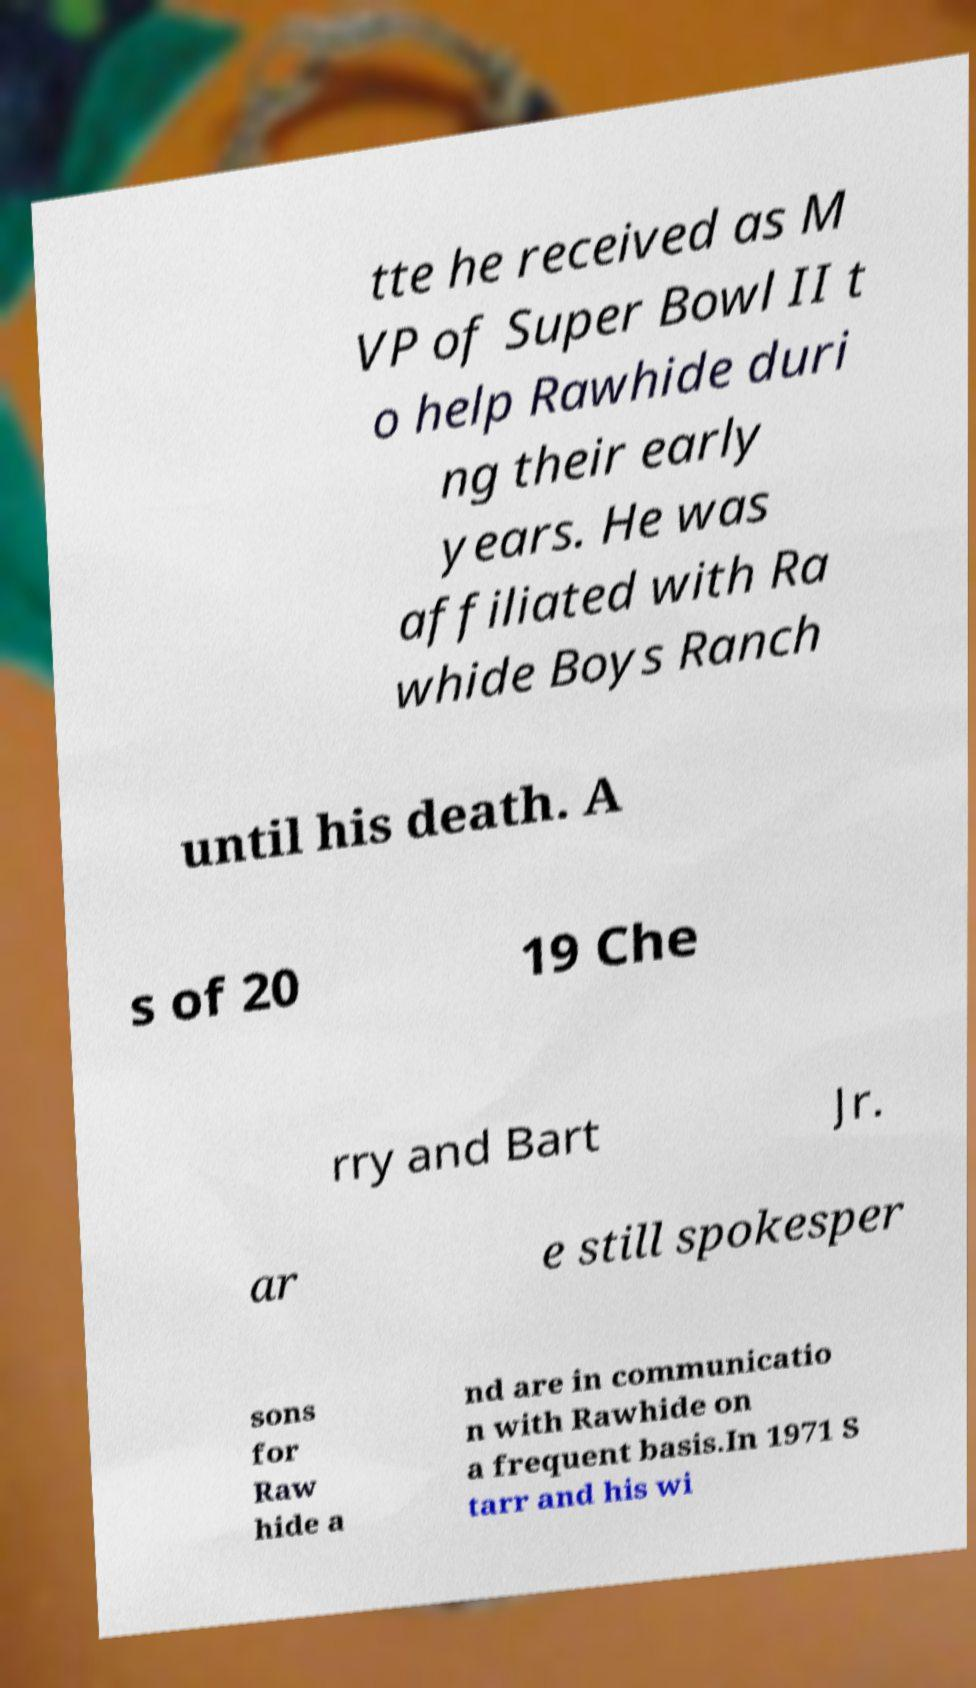There's text embedded in this image that I need extracted. Can you transcribe it verbatim? tte he received as M VP of Super Bowl II t o help Rawhide duri ng their early years. He was affiliated with Ra whide Boys Ranch until his death. A s of 20 19 Che rry and Bart Jr. ar e still spokesper sons for Raw hide a nd are in communicatio n with Rawhide on a frequent basis.In 1971 S tarr and his wi 